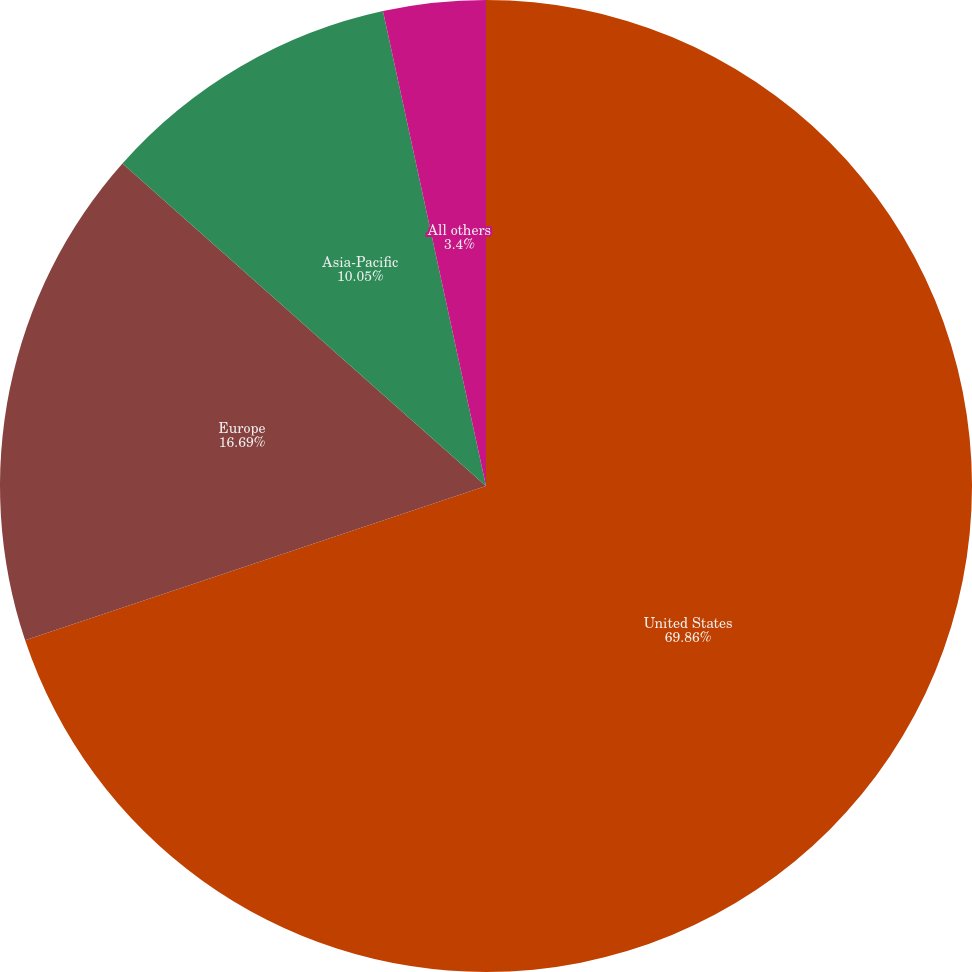Convert chart to OTSL. <chart><loc_0><loc_0><loc_500><loc_500><pie_chart><fcel>United States<fcel>Europe<fcel>Asia-Pacific<fcel>All others<nl><fcel>69.86%<fcel>16.69%<fcel>10.05%<fcel>3.4%<nl></chart> 